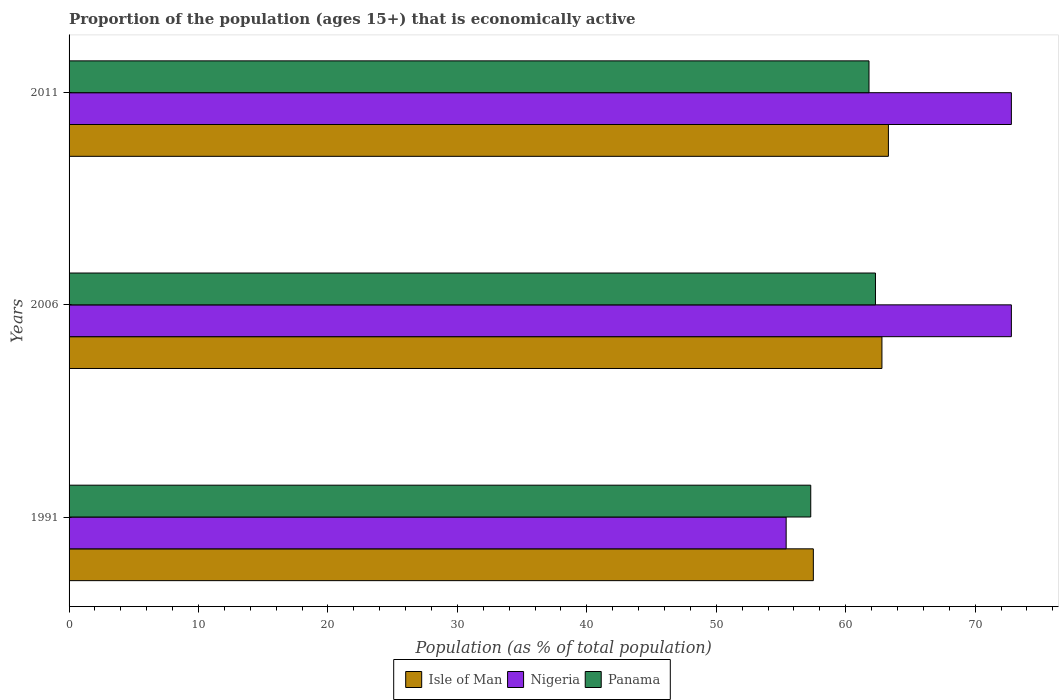How many groups of bars are there?
Keep it short and to the point. 3. Are the number of bars per tick equal to the number of legend labels?
Offer a very short reply. Yes. Are the number of bars on each tick of the Y-axis equal?
Your answer should be very brief. Yes. How many bars are there on the 2nd tick from the top?
Provide a succinct answer. 3. What is the label of the 1st group of bars from the top?
Offer a terse response. 2011. What is the proportion of the population that is economically active in Panama in 2011?
Offer a very short reply. 61.8. Across all years, what is the maximum proportion of the population that is economically active in Panama?
Offer a very short reply. 62.3. Across all years, what is the minimum proportion of the population that is economically active in Panama?
Make the answer very short. 57.3. In which year was the proportion of the population that is economically active in Isle of Man maximum?
Your response must be concise. 2011. What is the total proportion of the population that is economically active in Isle of Man in the graph?
Make the answer very short. 183.6. What is the difference between the proportion of the population that is economically active in Panama in 2006 and that in 2011?
Make the answer very short. 0.5. What is the difference between the proportion of the population that is economically active in Panama in 2006 and the proportion of the population that is economically active in Isle of Man in 2011?
Your answer should be compact. -1. What is the average proportion of the population that is economically active in Isle of Man per year?
Your response must be concise. 61.2. In the year 2011, what is the difference between the proportion of the population that is economically active in Nigeria and proportion of the population that is economically active in Isle of Man?
Your answer should be compact. 9.5. In how many years, is the proportion of the population that is economically active in Nigeria greater than 10 %?
Your answer should be very brief. 3. What is the ratio of the proportion of the population that is economically active in Panama in 1991 to that in 2006?
Provide a short and direct response. 0.92. Is the proportion of the population that is economically active in Nigeria in 1991 less than that in 2011?
Provide a short and direct response. Yes. What is the difference between the highest and the lowest proportion of the population that is economically active in Isle of Man?
Give a very brief answer. 5.8. In how many years, is the proportion of the population that is economically active in Panama greater than the average proportion of the population that is economically active in Panama taken over all years?
Your answer should be compact. 2. What does the 2nd bar from the top in 1991 represents?
Offer a very short reply. Nigeria. What does the 2nd bar from the bottom in 2011 represents?
Offer a very short reply. Nigeria. What is the difference between two consecutive major ticks on the X-axis?
Offer a terse response. 10. How many legend labels are there?
Your answer should be compact. 3. How are the legend labels stacked?
Your answer should be very brief. Horizontal. What is the title of the graph?
Provide a short and direct response. Proportion of the population (ages 15+) that is economically active. Does "Trinidad and Tobago" appear as one of the legend labels in the graph?
Keep it short and to the point. No. What is the label or title of the X-axis?
Provide a short and direct response. Population (as % of total population). What is the Population (as % of total population) of Isle of Man in 1991?
Keep it short and to the point. 57.5. What is the Population (as % of total population) in Nigeria in 1991?
Provide a short and direct response. 55.4. What is the Population (as % of total population) in Panama in 1991?
Your answer should be very brief. 57.3. What is the Population (as % of total population) of Isle of Man in 2006?
Ensure brevity in your answer.  62.8. What is the Population (as % of total population) in Nigeria in 2006?
Provide a short and direct response. 72.8. What is the Population (as % of total population) of Panama in 2006?
Your answer should be compact. 62.3. What is the Population (as % of total population) of Isle of Man in 2011?
Provide a short and direct response. 63.3. What is the Population (as % of total population) of Nigeria in 2011?
Make the answer very short. 72.8. What is the Population (as % of total population) of Panama in 2011?
Your answer should be very brief. 61.8. Across all years, what is the maximum Population (as % of total population) in Isle of Man?
Make the answer very short. 63.3. Across all years, what is the maximum Population (as % of total population) in Nigeria?
Your answer should be compact. 72.8. Across all years, what is the maximum Population (as % of total population) in Panama?
Give a very brief answer. 62.3. Across all years, what is the minimum Population (as % of total population) in Isle of Man?
Your answer should be compact. 57.5. Across all years, what is the minimum Population (as % of total population) of Nigeria?
Offer a terse response. 55.4. Across all years, what is the minimum Population (as % of total population) in Panama?
Make the answer very short. 57.3. What is the total Population (as % of total population) of Isle of Man in the graph?
Keep it short and to the point. 183.6. What is the total Population (as % of total population) in Nigeria in the graph?
Offer a terse response. 201. What is the total Population (as % of total population) in Panama in the graph?
Make the answer very short. 181.4. What is the difference between the Population (as % of total population) in Nigeria in 1991 and that in 2006?
Your answer should be compact. -17.4. What is the difference between the Population (as % of total population) in Nigeria in 1991 and that in 2011?
Give a very brief answer. -17.4. What is the difference between the Population (as % of total population) in Panama in 2006 and that in 2011?
Offer a terse response. 0.5. What is the difference between the Population (as % of total population) in Isle of Man in 1991 and the Population (as % of total population) in Nigeria in 2006?
Provide a succinct answer. -15.3. What is the difference between the Population (as % of total population) of Isle of Man in 1991 and the Population (as % of total population) of Panama in 2006?
Provide a short and direct response. -4.8. What is the difference between the Population (as % of total population) of Nigeria in 1991 and the Population (as % of total population) of Panama in 2006?
Make the answer very short. -6.9. What is the difference between the Population (as % of total population) in Isle of Man in 1991 and the Population (as % of total population) in Nigeria in 2011?
Your answer should be very brief. -15.3. What is the average Population (as % of total population) in Isle of Man per year?
Give a very brief answer. 61.2. What is the average Population (as % of total population) of Panama per year?
Offer a very short reply. 60.47. In the year 1991, what is the difference between the Population (as % of total population) of Isle of Man and Population (as % of total population) of Nigeria?
Keep it short and to the point. 2.1. In the year 1991, what is the difference between the Population (as % of total population) of Isle of Man and Population (as % of total population) of Panama?
Provide a succinct answer. 0.2. In the year 2006, what is the difference between the Population (as % of total population) of Isle of Man and Population (as % of total population) of Panama?
Provide a succinct answer. 0.5. In the year 2011, what is the difference between the Population (as % of total population) in Isle of Man and Population (as % of total population) in Nigeria?
Give a very brief answer. -9.5. In the year 2011, what is the difference between the Population (as % of total population) in Isle of Man and Population (as % of total population) in Panama?
Provide a short and direct response. 1.5. In the year 2011, what is the difference between the Population (as % of total population) of Nigeria and Population (as % of total population) of Panama?
Your answer should be very brief. 11. What is the ratio of the Population (as % of total population) in Isle of Man in 1991 to that in 2006?
Provide a succinct answer. 0.92. What is the ratio of the Population (as % of total population) of Nigeria in 1991 to that in 2006?
Your answer should be compact. 0.76. What is the ratio of the Population (as % of total population) of Panama in 1991 to that in 2006?
Ensure brevity in your answer.  0.92. What is the ratio of the Population (as % of total population) in Isle of Man in 1991 to that in 2011?
Give a very brief answer. 0.91. What is the ratio of the Population (as % of total population) of Nigeria in 1991 to that in 2011?
Give a very brief answer. 0.76. What is the ratio of the Population (as % of total population) in Panama in 1991 to that in 2011?
Provide a succinct answer. 0.93. What is the ratio of the Population (as % of total population) in Isle of Man in 2006 to that in 2011?
Your answer should be very brief. 0.99. What is the ratio of the Population (as % of total population) in Panama in 2006 to that in 2011?
Provide a short and direct response. 1.01. What is the difference between the highest and the lowest Population (as % of total population) of Nigeria?
Provide a succinct answer. 17.4. What is the difference between the highest and the lowest Population (as % of total population) in Panama?
Offer a terse response. 5. 